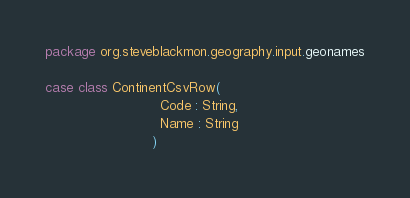Convert code to text. <code><loc_0><loc_0><loc_500><loc_500><_Scala_>package org.steveblackmon.geography.input.geonames

case class ContinentCsvRow(
                            Code : String,
                            Name : String
                          )
</code> 